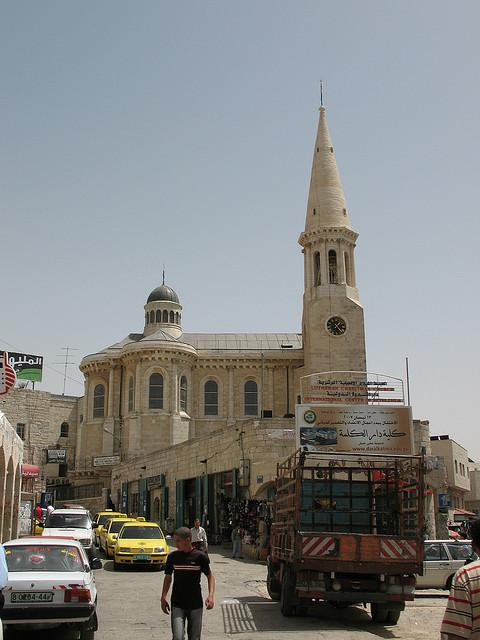What sound source can be found above the clock here?

Choices:
A) intercom
B) choir
C) boom box
D) bell bell 